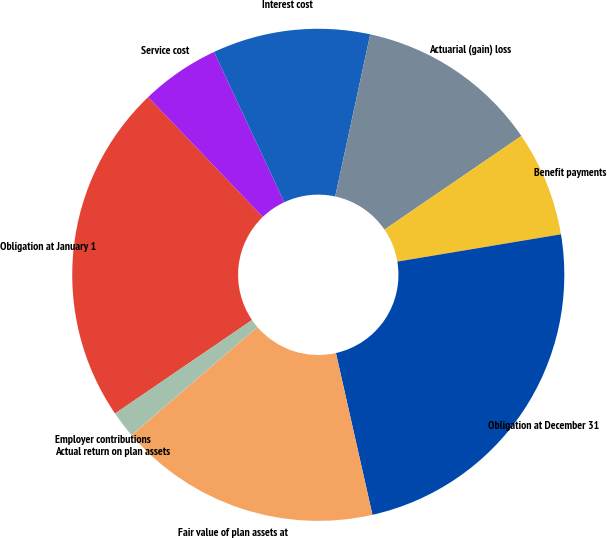<chart> <loc_0><loc_0><loc_500><loc_500><pie_chart><fcel>Obligation at January 1<fcel>Service cost<fcel>Interest cost<fcel>Actuarial (gain) loss<fcel>Benefit payments<fcel>Obligation at December 31<fcel>Fair value of plan assets at<fcel>Actual return on plan assets<fcel>Employer contributions<nl><fcel>22.38%<fcel>5.19%<fcel>10.35%<fcel>12.07%<fcel>6.91%<fcel>24.1%<fcel>17.22%<fcel>0.03%<fcel>1.75%<nl></chart> 